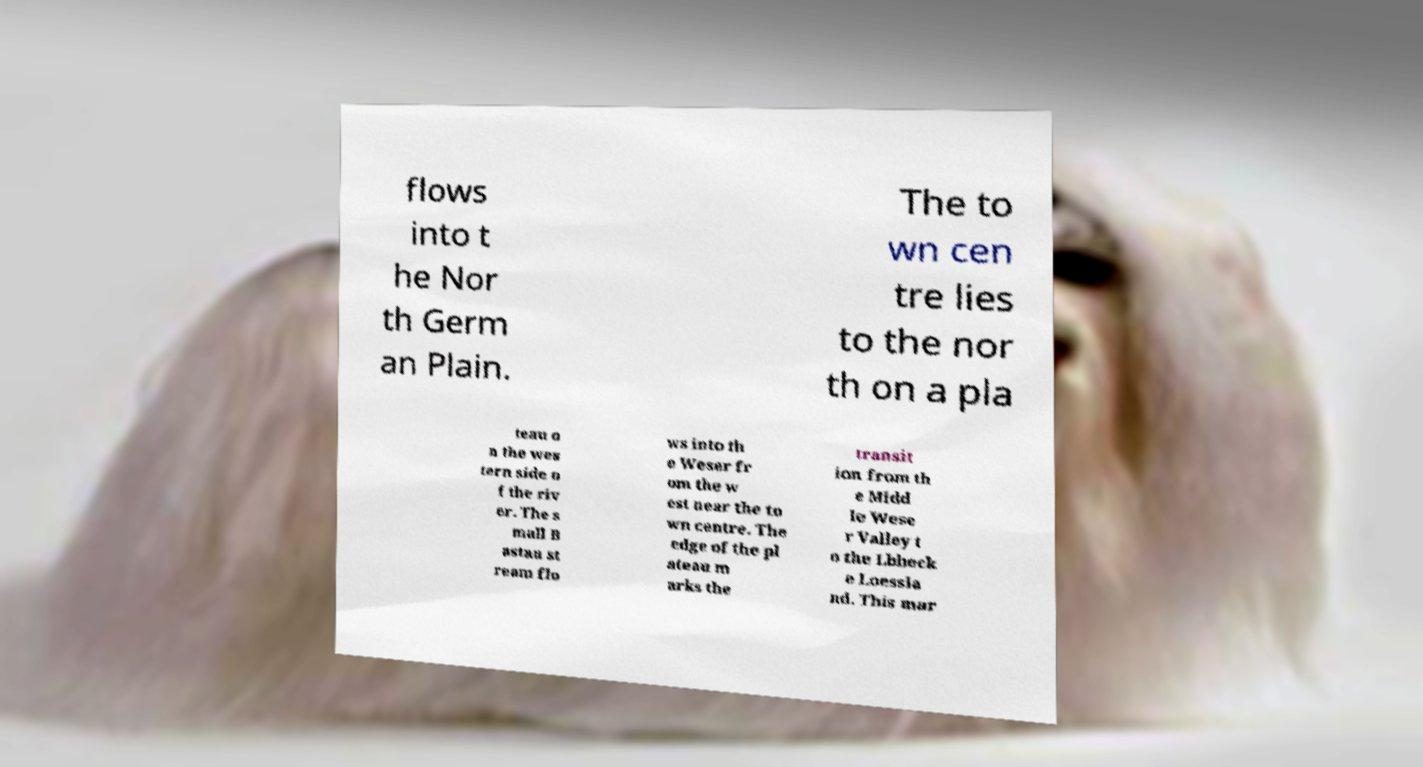Please identify and transcribe the text found in this image. flows into t he Nor th Germ an Plain. The to wn cen tre lies to the nor th on a pla teau o n the wes tern side o f the riv er. The s mall B astau st ream flo ws into th e Weser fr om the w est near the to wn centre. The edge of the pl ateau m arks the transit ion from th e Midd le Wese r Valley t o the Lbbeck e Loessla nd. This mar 